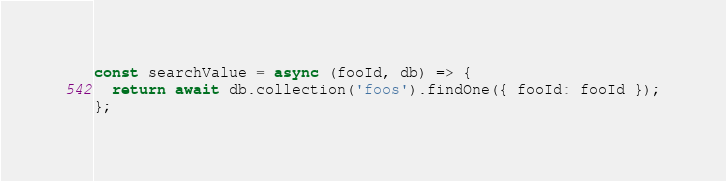<code> <loc_0><loc_0><loc_500><loc_500><_JavaScript_>const searchValue = async (fooId, db) => {
  return await db.collection('foos').findOne({ fooId: fooId });
};
</code> 